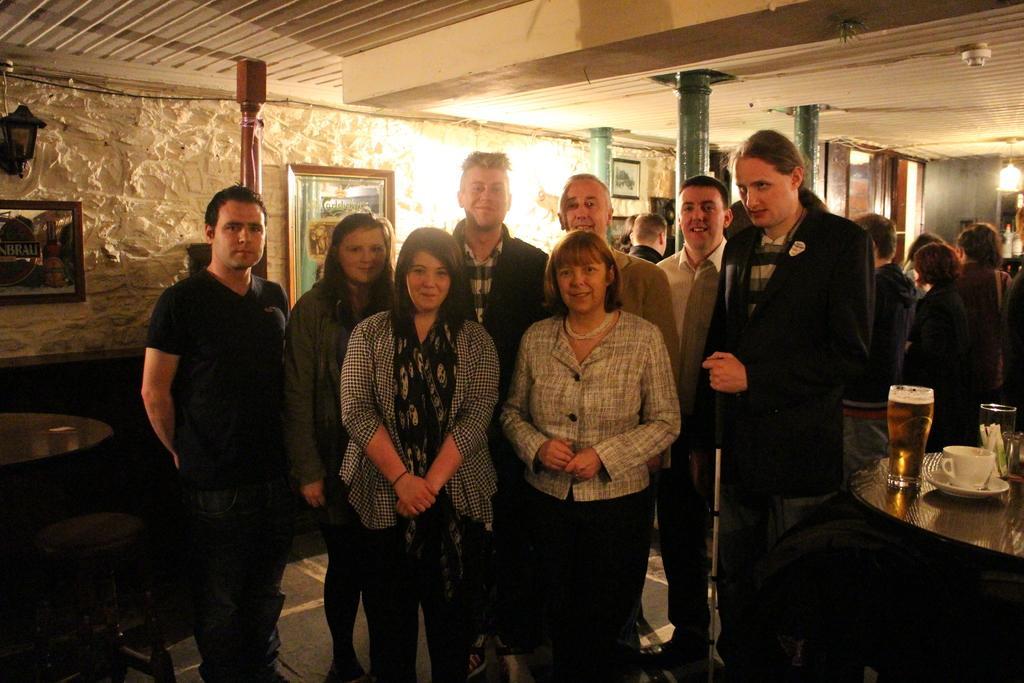Describe this image in one or two sentences. In this image we can see people standing. To the right side of the image there is a table on which there is a cup and saucer. There are glasses. In the background of the image there is wall with photo frames and light. At the top of the image there is ceiling. 